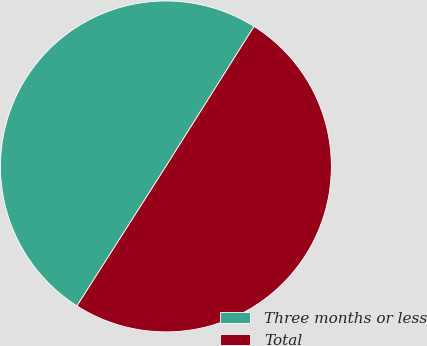Convert chart. <chart><loc_0><loc_0><loc_500><loc_500><pie_chart><fcel>Three months or less<fcel>Total<nl><fcel>49.91%<fcel>50.09%<nl></chart> 